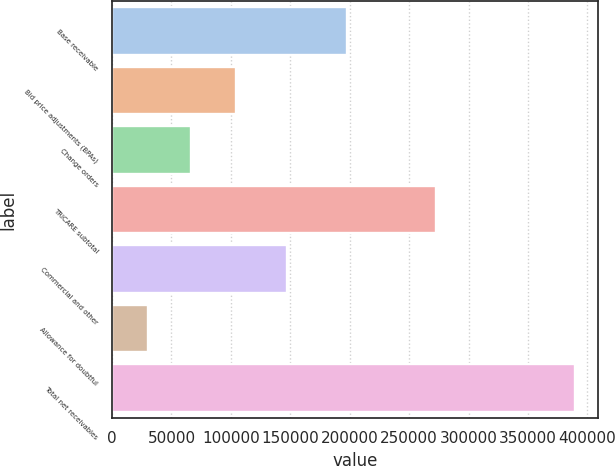<chart> <loc_0><loc_0><loc_500><loc_500><bar_chart><fcel>Base receivable<fcel>Bid price adjustments (BPAs)<fcel>Change orders<fcel>TRICARE subtotal<fcel>Commercial and other<fcel>Allowance for doubtful<fcel>Total net receivables<nl><fcel>197544<fcel>104044<fcel>66105.3<fcel>272747<fcel>146882<fcel>30178<fcel>389451<nl></chart> 